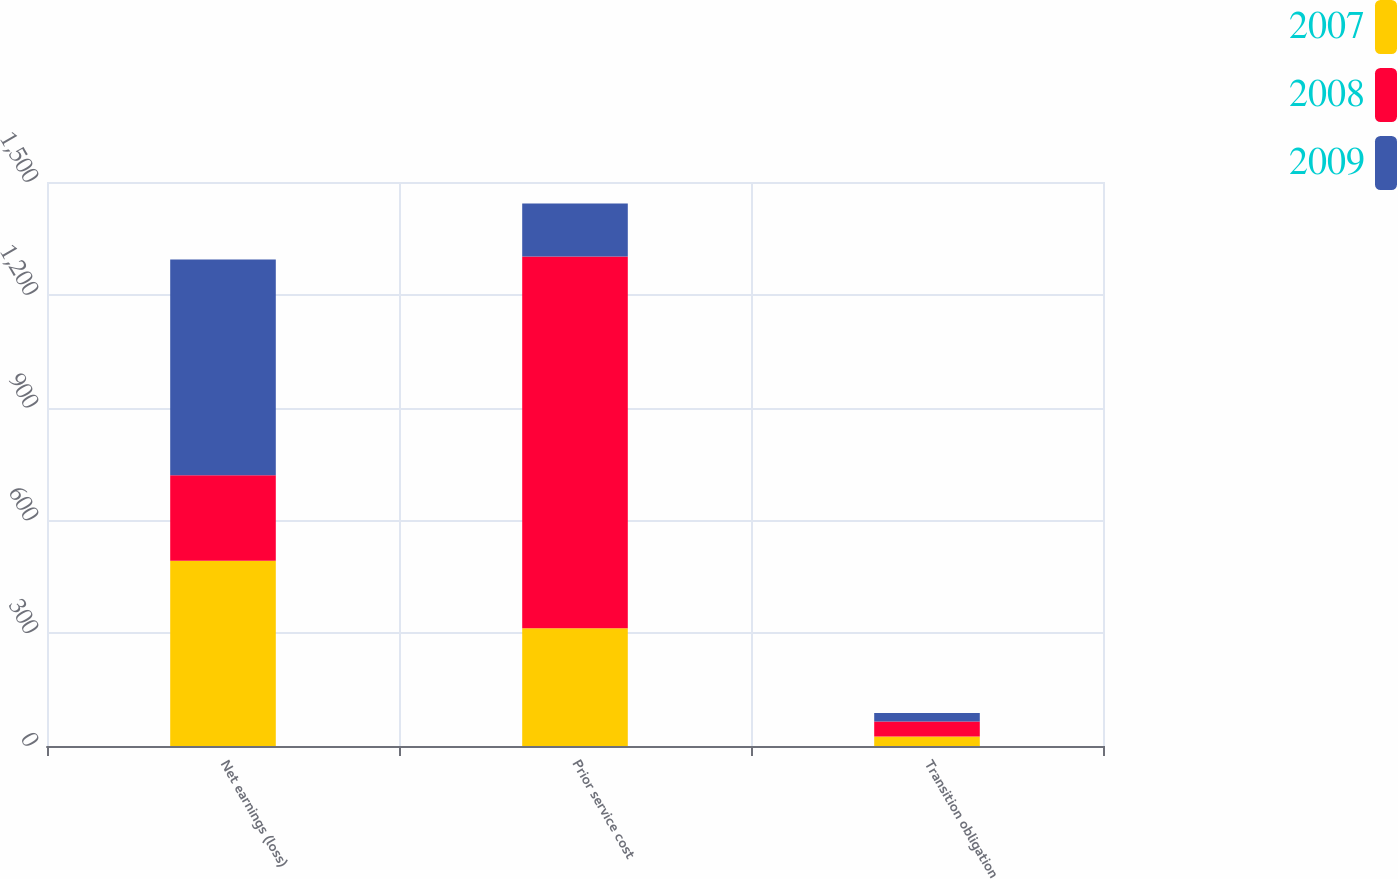Convert chart to OTSL. <chart><loc_0><loc_0><loc_500><loc_500><stacked_bar_chart><ecel><fcel>Net earnings (loss)<fcel>Prior service cost<fcel>Transition obligation<nl><fcel>2007<fcel>493<fcel>313<fcel>25<nl><fcel>2008<fcel>227<fcel>989<fcel>40<nl><fcel>2009<fcel>574<fcel>141<fcel>23<nl></chart> 